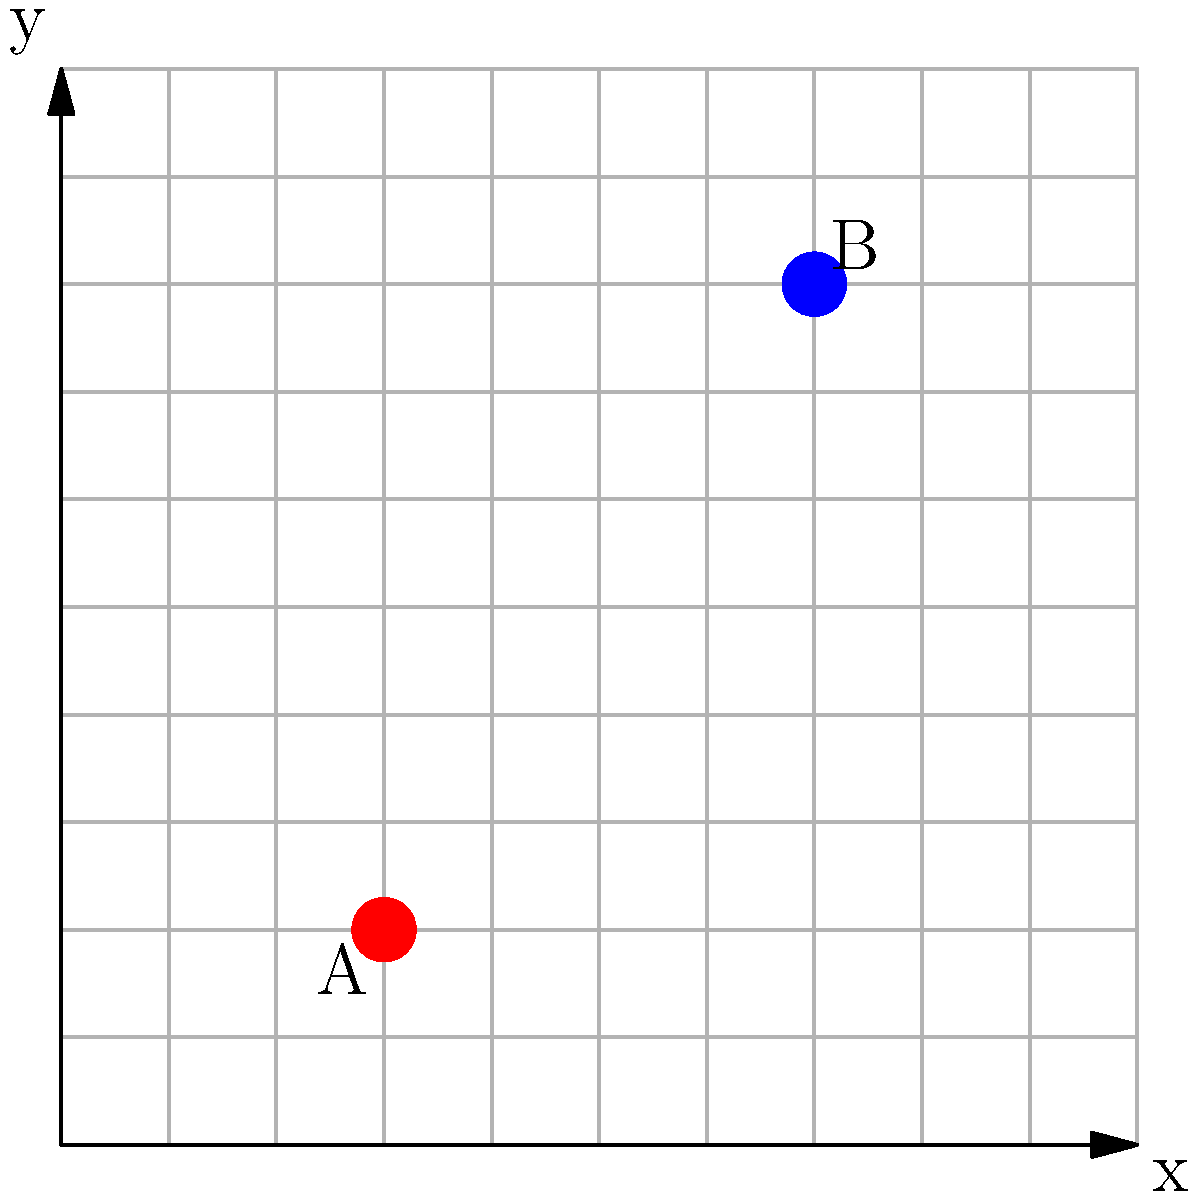In a boxing gym, two boxers (A and B) are training on a coordinate grid where each unit represents 1 meter. Boxer A is at position (3, 2), and Boxer B is at position (7, 8). To ensure safe distancing during training, boxers must maintain a minimum distance of 5 meters from each other. Are these boxers training at a safe distance from each other? If not, what is the minimum additional distance they need to move apart to meet the safety requirement? To solve this problem, we need to follow these steps:

1) Calculate the current distance between the boxers using the distance formula:
   $$d = \sqrt{(x_2-x_1)^2 + (y_2-y_1)^2}$$

2) For Boxer A (3, 2) and Boxer B (7, 8):
   $$d = \sqrt{(7-3)^2 + (8-2)^2}$$
   $$d = \sqrt{4^2 + 6^2}$$
   $$d = \sqrt{16 + 36}$$
   $$d = \sqrt{52}$$
   $$d \approx 7.21 \text{ meters}$$

3) The current distance (7.21 meters) is greater than the minimum safe distance (5 meters).

4) Therefore, the boxers are already training at a safe distance from each other.

5) The additional distance they need to move apart is 0 meters, as they already meet the safety requirement.
Answer: Yes, safe distance; 0 meters additional distance needed. 